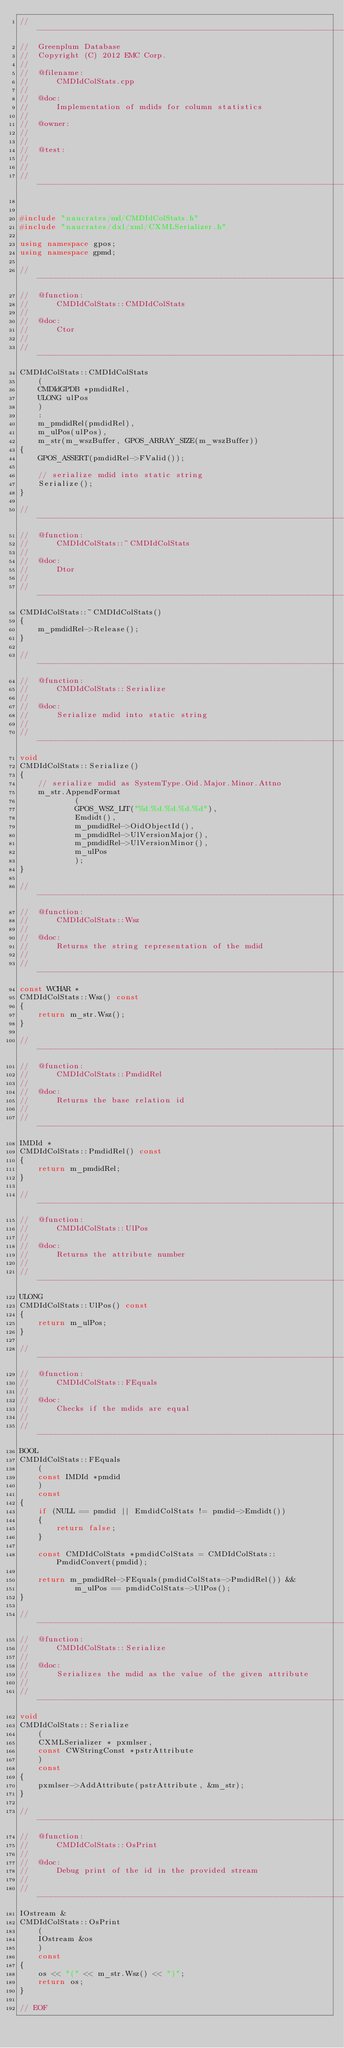Convert code to text. <code><loc_0><loc_0><loc_500><loc_500><_C++_>//---------------------------------------------------------------------------
//	Greenplum Database
//	Copyright (C) 2012 EMC Corp.
//
//	@filename:
//		CMDIdColStats.cpp
//
//	@doc:
//		Implementation of mdids for column statistics
//
//	@owner: 
//		
//
//	@test:
//
//
//---------------------------------------------------------------------------


#include "naucrates/md/CMDIdColStats.h"
#include "naucrates/dxl/xml/CXMLSerializer.h"

using namespace gpos;
using namespace gpmd;

//---------------------------------------------------------------------------
//	@function:
//		CMDIdColStats::CMDIdColStats
//
//	@doc:
//		Ctor
//
//---------------------------------------------------------------------------
CMDIdColStats::CMDIdColStats
	(
	CMDIdGPDB *pmdidRel,
	ULONG ulPos
	)
	:
	m_pmdidRel(pmdidRel),
	m_ulPos(ulPos),
	m_str(m_wszBuffer, GPOS_ARRAY_SIZE(m_wszBuffer))
{
	GPOS_ASSERT(pmdidRel->FValid());
	
	// serialize mdid into static string 
	Serialize();
}

//---------------------------------------------------------------------------
//	@function:
//		CMDIdColStats::~CMDIdColStats
//
//	@doc:
//		Dtor
//
//---------------------------------------------------------------------------
CMDIdColStats::~CMDIdColStats()
{
	m_pmdidRel->Release();
}

//---------------------------------------------------------------------------
//	@function:
//		CMDIdColStats::Serialize
//
//	@doc:
//		Serialize mdid into static string
//
//---------------------------------------------------------------------------
void
CMDIdColStats::Serialize()
{
	// serialize mdid as SystemType.Oid.Major.Minor.Attno
	m_str.AppendFormat
			(
			GPOS_WSZ_LIT("%d.%d.%d.%d.%d"), 
			Emdidt(), 
			m_pmdidRel->OidObjectId(),
			m_pmdidRel->UlVersionMajor(),
			m_pmdidRel->UlVersionMinor(),
			m_ulPos
			);
}

//---------------------------------------------------------------------------
//	@function:
//		CMDIdColStats::Wsz
//
//	@doc:
//		Returns the string representation of the mdid
//
//---------------------------------------------------------------------------
const WCHAR *
CMDIdColStats::Wsz() const
{
	return m_str.Wsz();
}

//---------------------------------------------------------------------------
//	@function:
//		CMDIdColStats::PmdidRel
//
//	@doc:
//		Returns the base relation id
//
//---------------------------------------------------------------------------
IMDId *
CMDIdColStats::PmdidRel() const
{
	return m_pmdidRel;
}

//---------------------------------------------------------------------------
//	@function:
//		CMDIdColStats::UlPos
//
//	@doc:
//		Returns the attribute number
//
//---------------------------------------------------------------------------
ULONG
CMDIdColStats::UlPos() const
{
	return m_ulPos;
}

//---------------------------------------------------------------------------
//	@function:
//		CMDIdColStats::FEquals
//
//	@doc:
//		Checks if the mdids are equal
//
//---------------------------------------------------------------------------
BOOL
CMDIdColStats::FEquals
	(
	const IMDId *pmdid
	) 
	const
{
	if (NULL == pmdid || EmdidColStats != pmdid->Emdidt())
	{
		return false;
	}
	
	const CMDIdColStats *pmdidColStats = CMDIdColStats::PmdidConvert(pmdid);
	
	return m_pmdidRel->FEquals(pmdidColStats->PmdidRel()) && 
			m_ulPos == pmdidColStats->UlPos(); 
}

//---------------------------------------------------------------------------
//	@function:
//		CMDIdColStats::Serialize
//
//	@doc:
//		Serializes the mdid as the value of the given attribute
//
//---------------------------------------------------------------------------
void
CMDIdColStats::Serialize
	(
	CXMLSerializer * pxmlser,
	const CWStringConst *pstrAttribute
	)
	const
{
	pxmlser->AddAttribute(pstrAttribute, &m_str);
}

//---------------------------------------------------------------------------
//	@function:
//		CMDIdColStats::OsPrint
//
//	@doc:
//		Debug print of the id in the provided stream
//
//---------------------------------------------------------------------------
IOstream &
CMDIdColStats::OsPrint
	(
	IOstream &os
	) 
	const
{
	os << "(" << m_str.Wsz() << ")";
	return os;
}

// EOF
</code> 